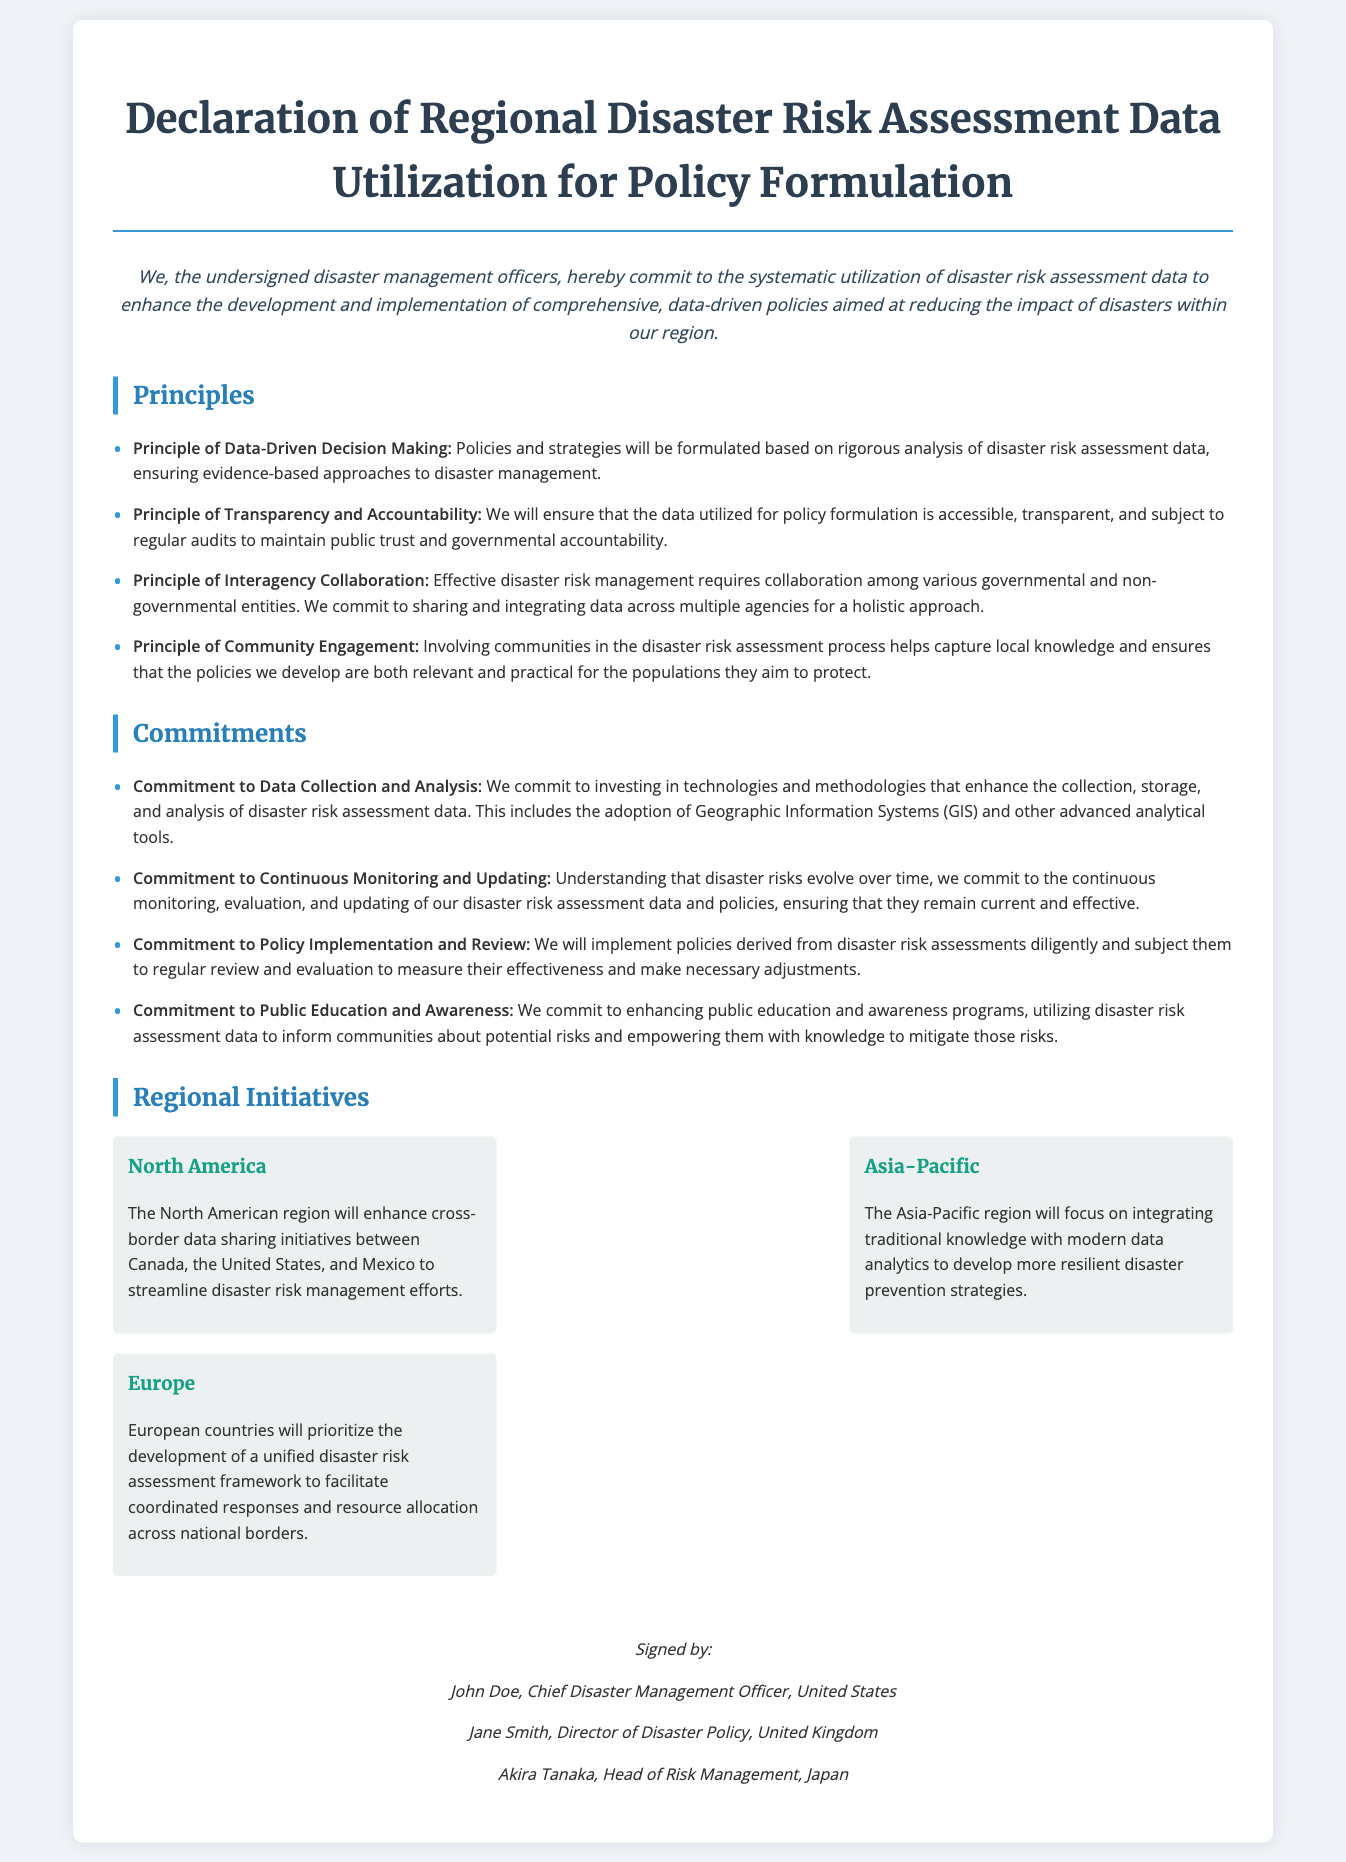What is the title of the document? The title of the document is stated at the top, highlighting its purpose regarding disaster risk assessment data.
Answer: Declaration of Regional Disaster Risk Assessment Data Utilization for Policy Formulation Who is the Chief Disaster Management Officer? The document lists the signatories along with their titles and affiliations, providing names of key individuals responsible for disaster management policies.
Answer: John Doe What principle emphasizes community involvement? The document outlines several principles, including one that stresses the importance of community engagement in the disaster risk assessment process.
Answer: Principle of Community Engagement How many regional initiatives are listed in the document? The section on regional initiatives includes three distinct regions, each with a brief description of its focus area.
Answer: Three What commitment involves the use of technologies for data analysis? A specific commitment addresses the necessity of investing in technologies and methodologies aimed at improving data collection and analysis related to disaster risk assessments.
Answer: Commitment to Data Collection and Analysis Which region plans to enhance cross-border data sharing initiatives? The document specifies a regional initiative aimed at improving data sharing for effective disaster management between certain countries.
Answer: North America What is the focus of the Asia-Pacific region's initiatives? The Asia-Pacific regional initiative highlights the integration of traditional knowledge with modern data analytics as a method to enhance disaster prevention strategies.
Answer: Integrating traditional knowledge with modern data analytics What is a key aspect of the principle of transparency? This principle addresses the need for data to be accessible and subject to audits, ensuring public trust in the process.
Answer: Accessibility and audits Who is the Director of Disaster Policy? The signatories section provides the names and titles of individuals, specifying their roles in the disaster management field.
Answer: Jane Smith 